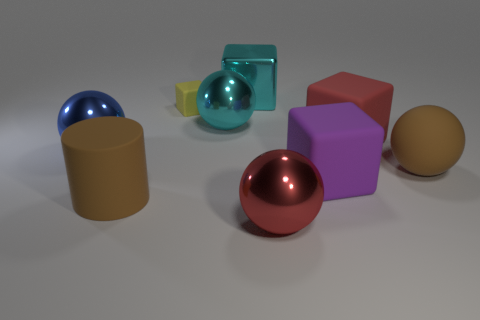Subtract 1 balls. How many balls are left? 3 Subtract all gray cubes. Subtract all green cylinders. How many cubes are left? 4 Subtract all tiny gray shiny blocks. Subtract all large brown matte cylinders. How many objects are left? 8 Add 3 big rubber balls. How many big rubber balls are left? 4 Add 4 shiny spheres. How many shiny spheres exist? 7 Subtract 1 brown cylinders. How many objects are left? 8 Subtract all blocks. How many objects are left? 5 